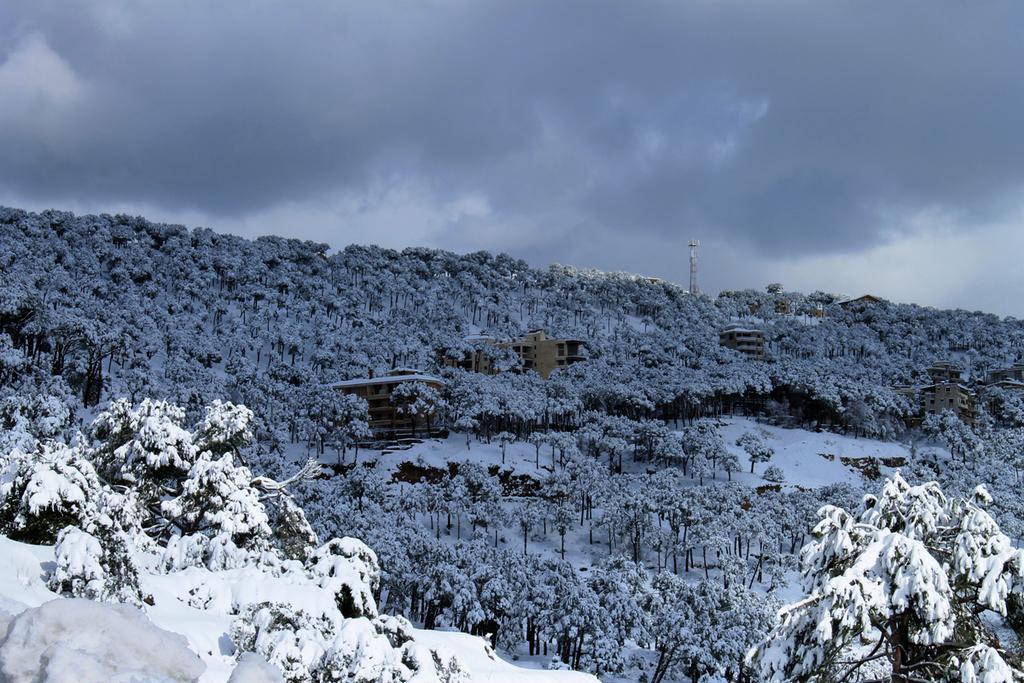Can you describe this image briefly? In this picture we can see trees, buildings, snow, tower and in the background we can see the sky with clouds. 